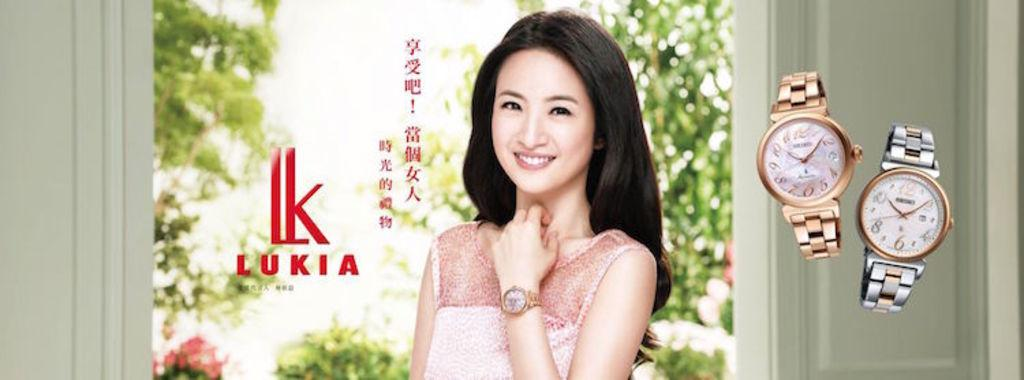Who is present in the image? There is a woman in the image. What is the woman doing in the image? The woman is smiling in the image. What can be seen in the background of the image? There are trees in the background of the image. What is written or depicted beside the woman? There is text beside the woman. What type of accessory can be seen on the right side of the image? There are two watches visible on the right side of the image. How does the woman push the brick in the image? There is no brick present in the image, so the woman cannot push a brick. 